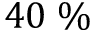<formula> <loc_0><loc_0><loc_500><loc_500>4 0 \, \%</formula> 